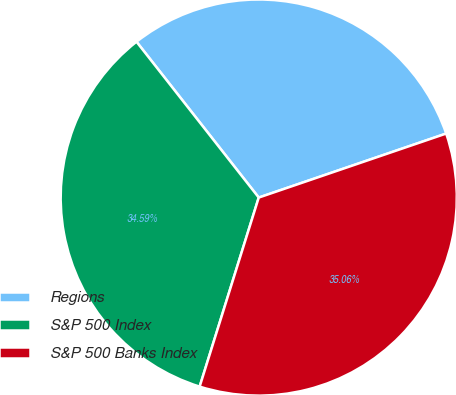Convert chart to OTSL. <chart><loc_0><loc_0><loc_500><loc_500><pie_chart><fcel>Regions<fcel>S&P 500 Index<fcel>S&P 500 Banks Index<nl><fcel>30.35%<fcel>34.59%<fcel>35.06%<nl></chart> 